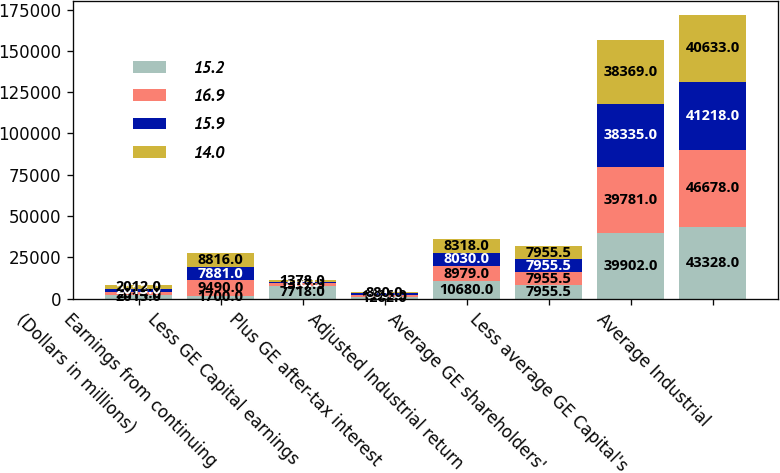Convert chart. <chart><loc_0><loc_0><loc_500><loc_500><stacked_bar_chart><ecel><fcel>(Dollars in millions)<fcel>Earnings from continuing<fcel>Less GE Capital earnings<fcel>Plus GE after-tax interest<fcel>Adjusted Industrial return<fcel>Average GE shareholders'<fcel>Less average GE Capital's<fcel>Average Industrial<nl><fcel>15.2<fcel>2015<fcel>1700<fcel>7718<fcel>1262<fcel>10680<fcel>7955.5<fcel>39902<fcel>43328<nl><fcel>16.9<fcel>2014<fcel>9490<fcel>1537<fcel>1026<fcel>8979<fcel>7955.5<fcel>39781<fcel>46678<nl><fcel>15.9<fcel>2013<fcel>7881<fcel>716<fcel>865<fcel>8030<fcel>7955.5<fcel>38335<fcel>41218<nl><fcel>14<fcel>2012<fcel>8816<fcel>1378<fcel>880<fcel>8318<fcel>7955.5<fcel>38369<fcel>40633<nl></chart> 